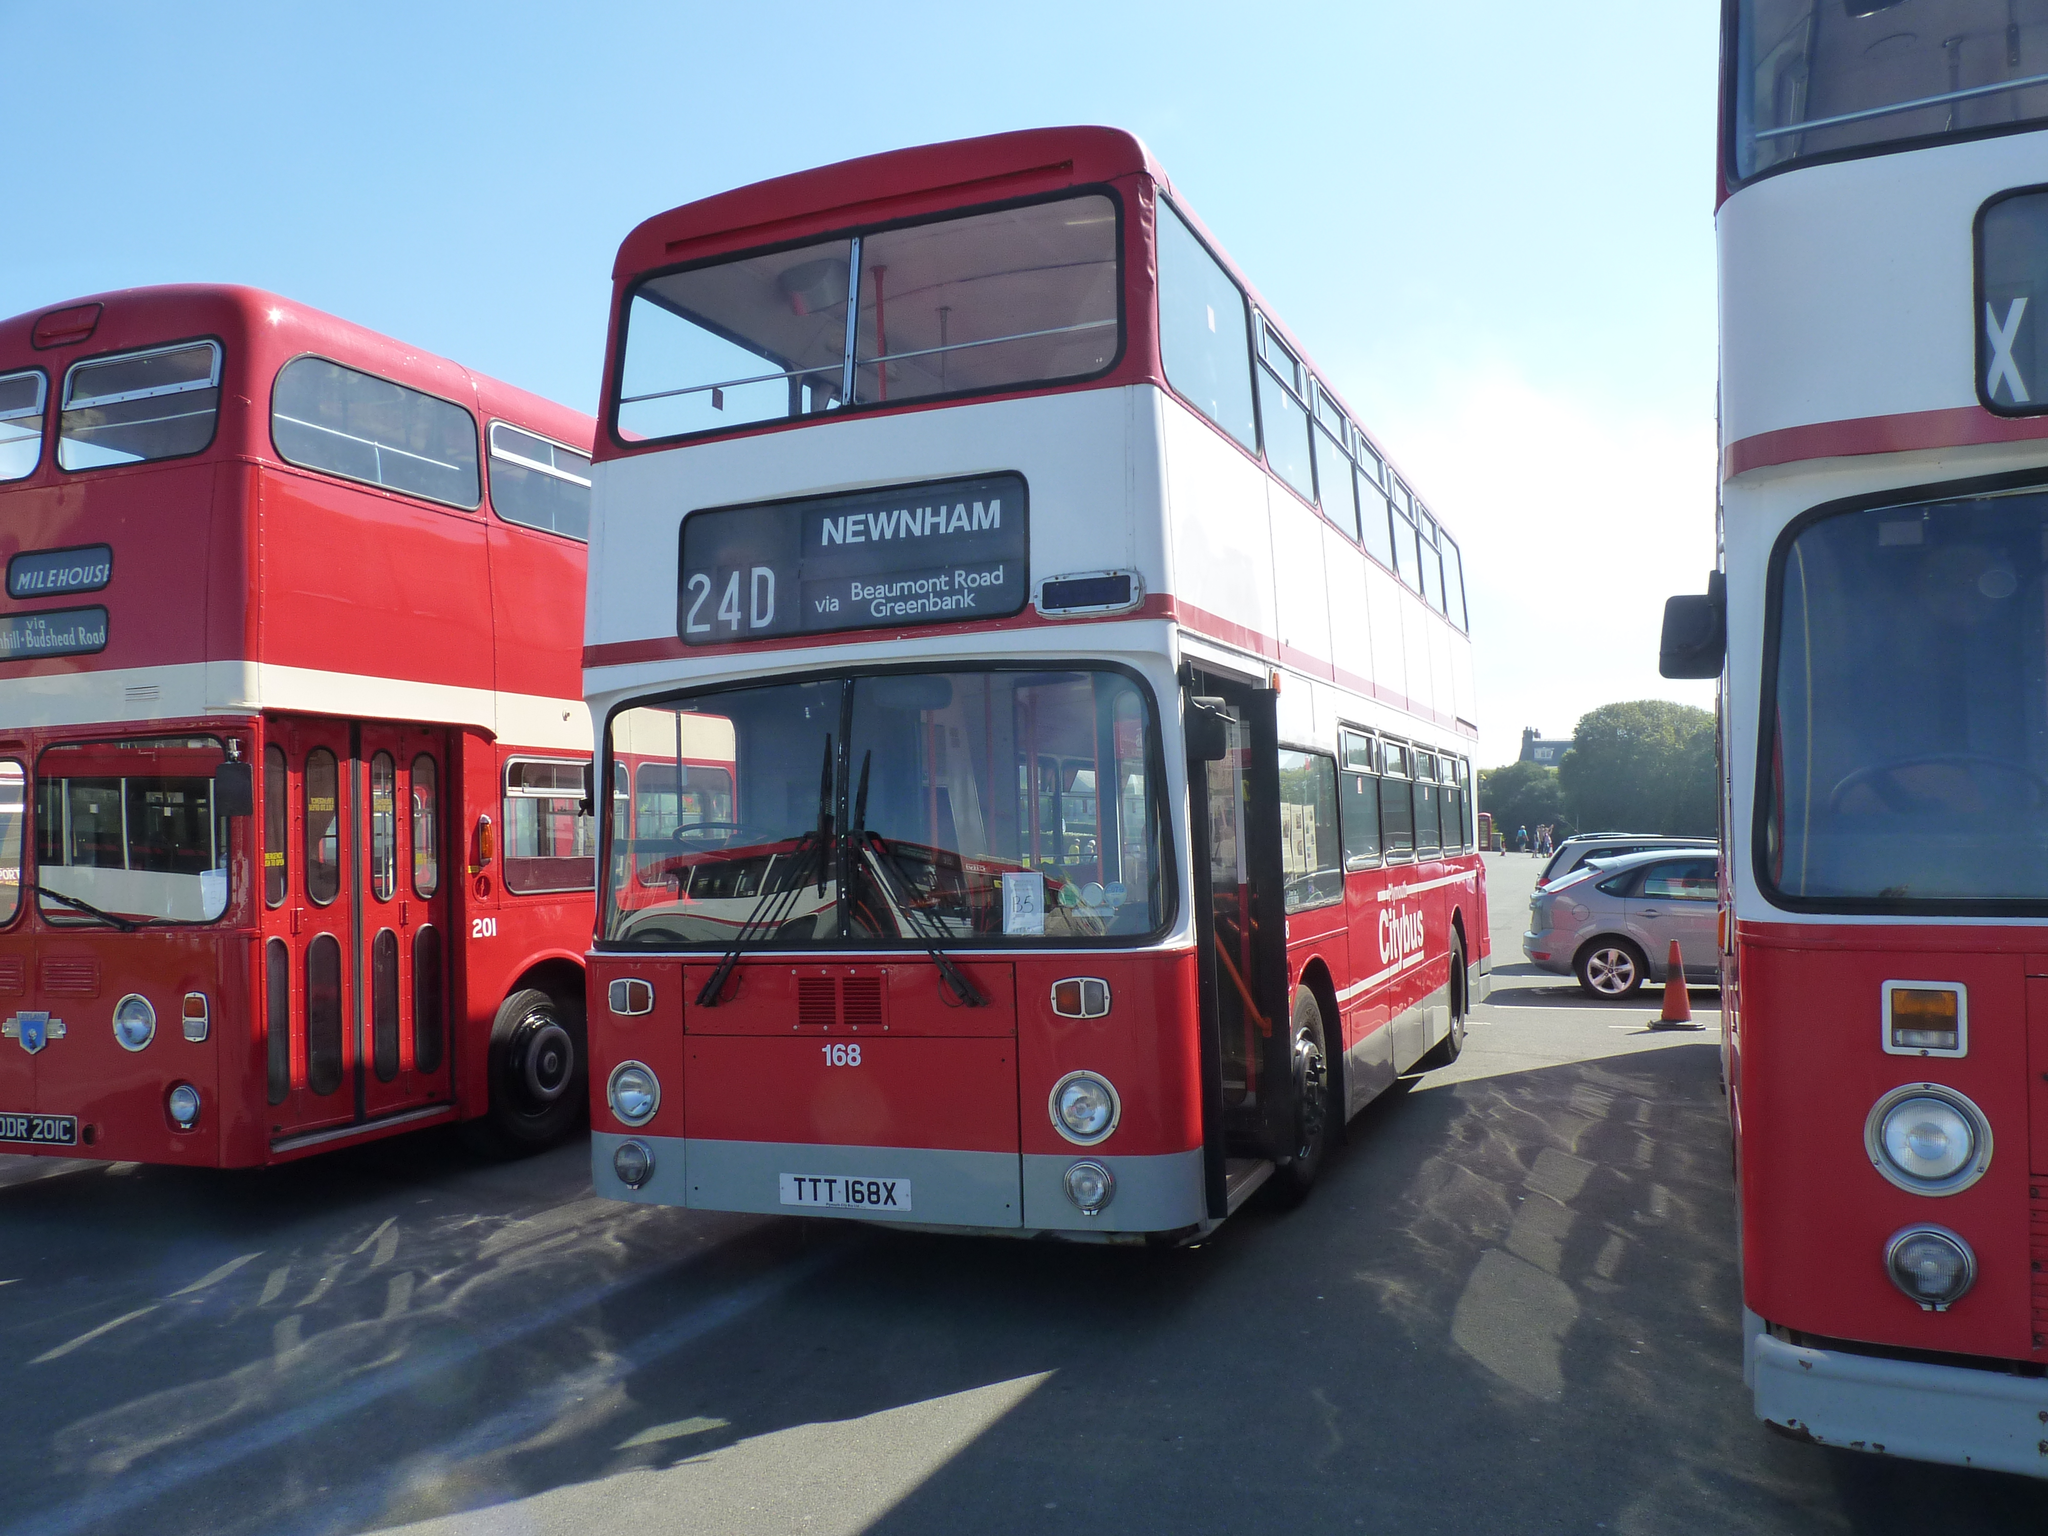<image>
Share a concise interpretation of the image provided. Double Decker red bus with 24D Newham white lettering on front. 